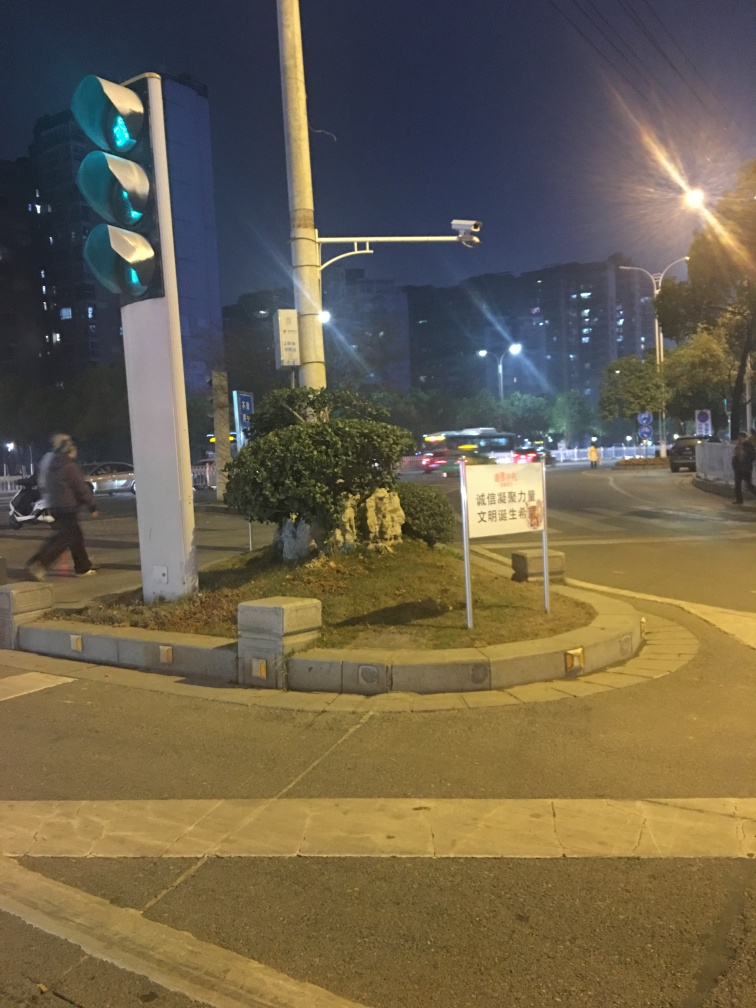What is the composition of the image?
A. rotated
B. slight tilt
C. upright
Answer with the option's letter from the given choices directly. The photo composition leans towards option B, which suggests a slight tilt, as evidenced by the angles of the traffic light pole and the straight lines of the curb, which do not appear perfectly vertical or horizontal. 